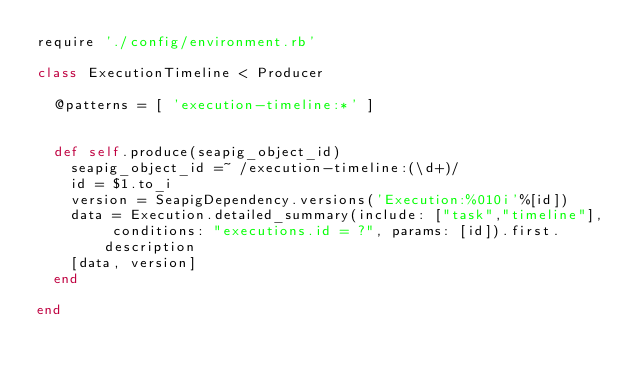<code> <loc_0><loc_0><loc_500><loc_500><_Ruby_>require './config/environment.rb'

class ExecutionTimeline < Producer

	@patterns = [ 'execution-timeline:*' ]


	def self.produce(seapig_object_id)
		seapig_object_id =~ /execution-timeline:(\d+)/
		id = $1.to_i
		version = SeapigDependency.versions('Execution:%010i'%[id])
		data = Execution.detailed_summary(include: ["task","timeline"], conditions: "executions.id = ?", params: [id]).first.description
		[data, version]
	end

end
</code> 